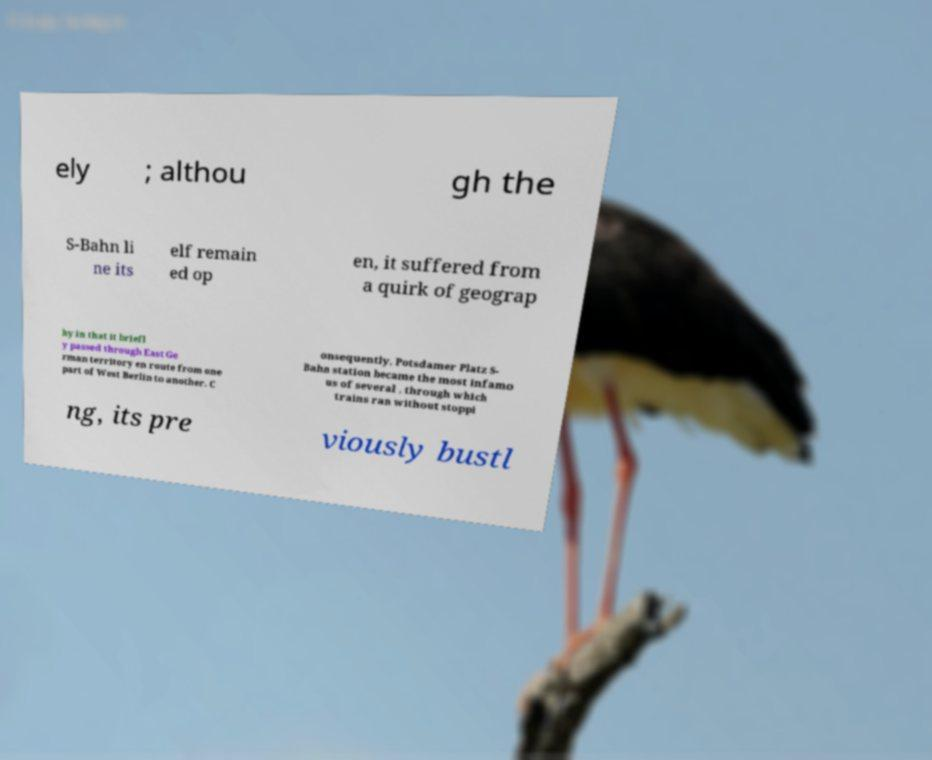Could you assist in decoding the text presented in this image and type it out clearly? ely ; althou gh the S-Bahn li ne its elf remain ed op en, it suffered from a quirk of geograp hy in that it briefl y passed through East Ge rman territory en route from one part of West Berlin to another. C onsequently, Potsdamer Platz S- Bahn station became the most infamo us of several , through which trains ran without stoppi ng, its pre viously bustl 